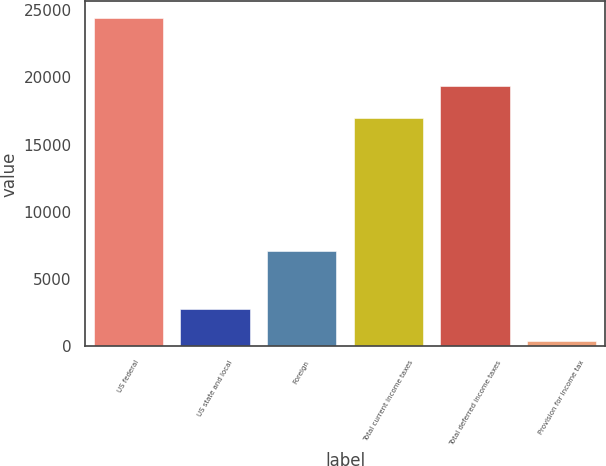<chart> <loc_0><loc_0><loc_500><loc_500><bar_chart><fcel>US federal<fcel>US state and local<fcel>Foreign<fcel>Total current income taxes<fcel>Total deferred income taxes<fcel>Provision for income tax<nl><fcel>24418<fcel>2808.1<fcel>7052<fcel>16953<fcel>19354.1<fcel>407<nl></chart> 